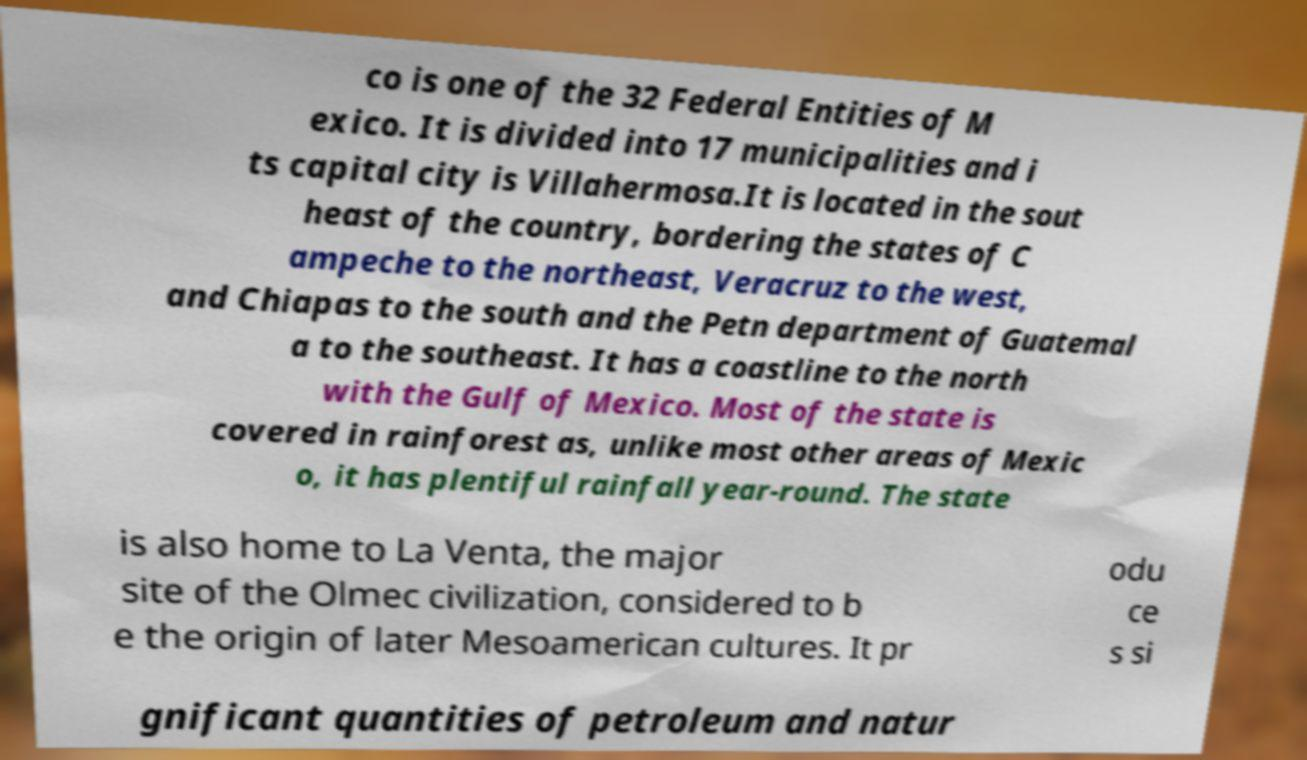What messages or text are displayed in this image? I need them in a readable, typed format. co is one of the 32 Federal Entities of M exico. It is divided into 17 municipalities and i ts capital city is Villahermosa.It is located in the sout heast of the country, bordering the states of C ampeche to the northeast, Veracruz to the west, and Chiapas to the south and the Petn department of Guatemal a to the southeast. It has a coastline to the north with the Gulf of Mexico. Most of the state is covered in rainforest as, unlike most other areas of Mexic o, it has plentiful rainfall year-round. The state is also home to La Venta, the major site of the Olmec civilization, considered to b e the origin of later Mesoamerican cultures. It pr odu ce s si gnificant quantities of petroleum and natur 